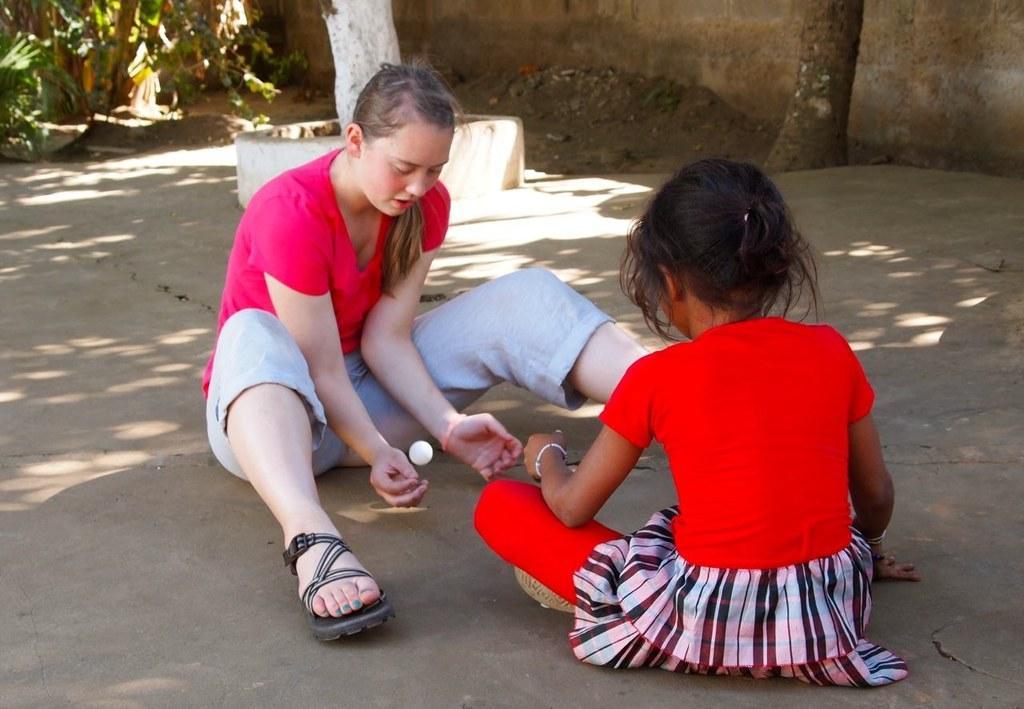Can you describe this image briefly? In this image in the center there are two girls sitting and they are playing with ball. At the bottom there is walkway, and in the background there is sand and some trees and a wall. 